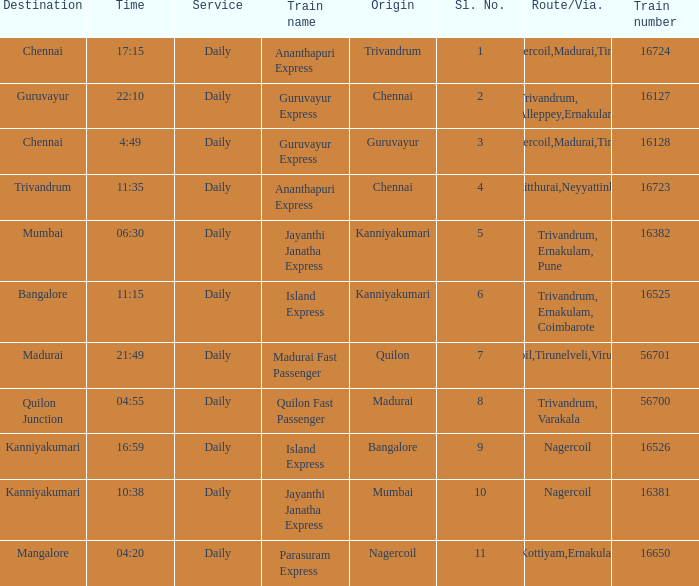What is the train number when the time is 10:38? 16381.0. 